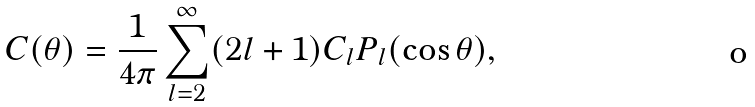Convert formula to latex. <formula><loc_0><loc_0><loc_500><loc_500>C ( \theta ) = \frac { 1 } { 4 \pi } \sum ^ { \infty } _ { l = 2 } ( 2 l + 1 ) C _ { l } P _ { l } ( \cos \theta ) ,</formula> 